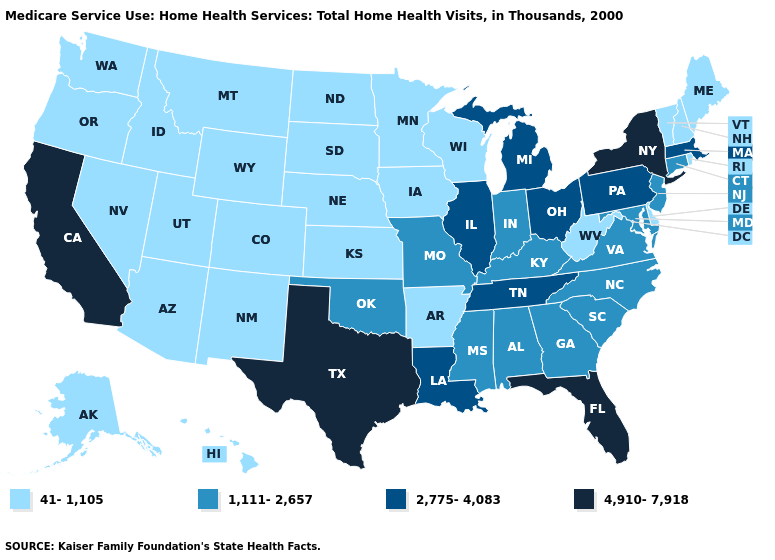Which states hav the highest value in the MidWest?
Write a very short answer. Illinois, Michigan, Ohio. Does Oregon have the highest value in the West?
Keep it brief. No. What is the value of New Hampshire?
Be succinct. 41-1,105. Name the states that have a value in the range 41-1,105?
Keep it brief. Alaska, Arizona, Arkansas, Colorado, Delaware, Hawaii, Idaho, Iowa, Kansas, Maine, Minnesota, Montana, Nebraska, Nevada, New Hampshire, New Mexico, North Dakota, Oregon, Rhode Island, South Dakota, Utah, Vermont, Washington, West Virginia, Wisconsin, Wyoming. Is the legend a continuous bar?
Short answer required. No. Among the states that border Pennsylvania , which have the lowest value?
Answer briefly. Delaware, West Virginia. Which states hav the highest value in the West?
Short answer required. California. Name the states that have a value in the range 1,111-2,657?
Quick response, please. Alabama, Connecticut, Georgia, Indiana, Kentucky, Maryland, Mississippi, Missouri, New Jersey, North Carolina, Oklahoma, South Carolina, Virginia. Does the first symbol in the legend represent the smallest category?
Be succinct. Yes. What is the value of Virginia?
Be succinct. 1,111-2,657. Which states have the lowest value in the USA?
Be succinct. Alaska, Arizona, Arkansas, Colorado, Delaware, Hawaii, Idaho, Iowa, Kansas, Maine, Minnesota, Montana, Nebraska, Nevada, New Hampshire, New Mexico, North Dakota, Oregon, Rhode Island, South Dakota, Utah, Vermont, Washington, West Virginia, Wisconsin, Wyoming. Among the states that border West Virginia , does Ohio have the lowest value?
Answer briefly. No. How many symbols are there in the legend?
Concise answer only. 4. What is the highest value in states that border North Carolina?
Concise answer only. 2,775-4,083. 